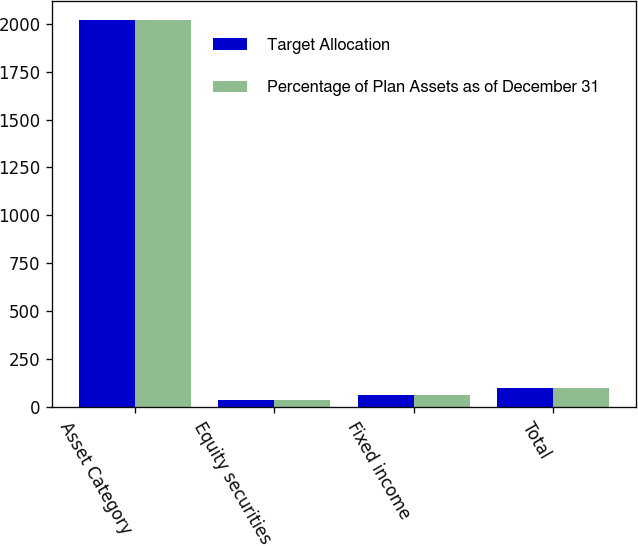<chart> <loc_0><loc_0><loc_500><loc_500><stacked_bar_chart><ecel><fcel>Asset Category<fcel>Equity securities<fcel>Fixed income<fcel>Total<nl><fcel>Target Allocation<fcel>2018<fcel>38<fcel>62<fcel>100<nl><fcel>Percentage of Plan Assets as of December 31<fcel>2017<fcel>35<fcel>65<fcel>100<nl></chart> 